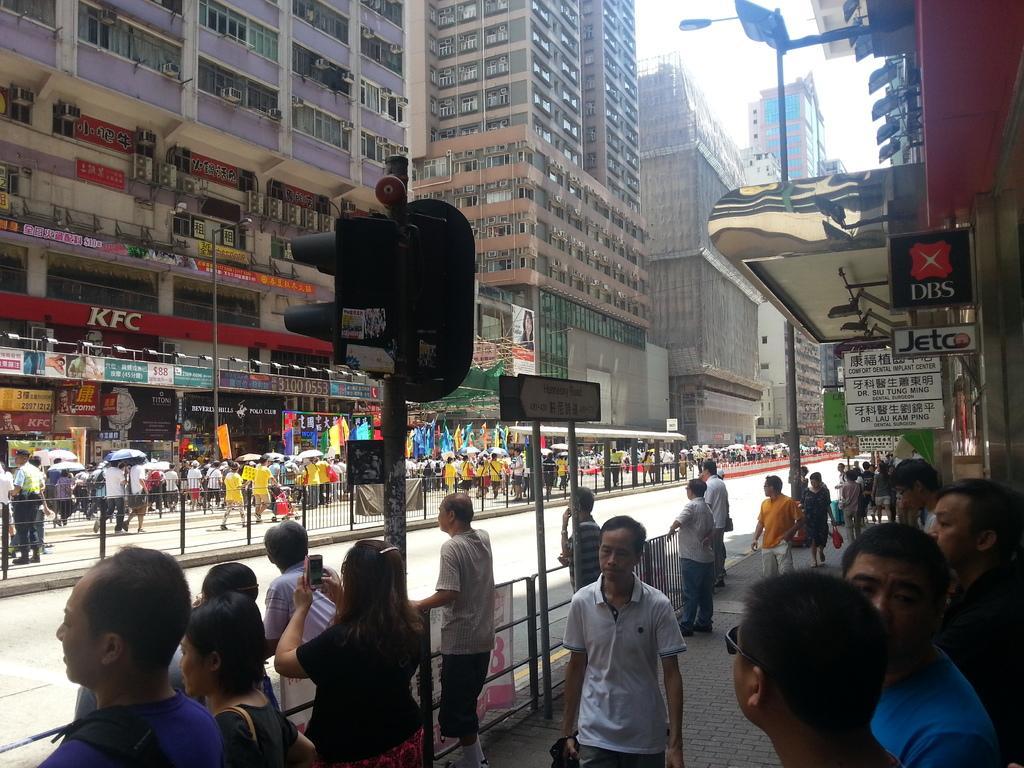In one or two sentences, can you explain what this image depicts? In the image we can see there are many people around and they are wearing clothes. They are walking and some of them are standing. Here we can see buildings and windows of the buildings. We can see light poles, signal pole and the boards, on the boards we can see the text. Here we can see fence, road and the sky. 